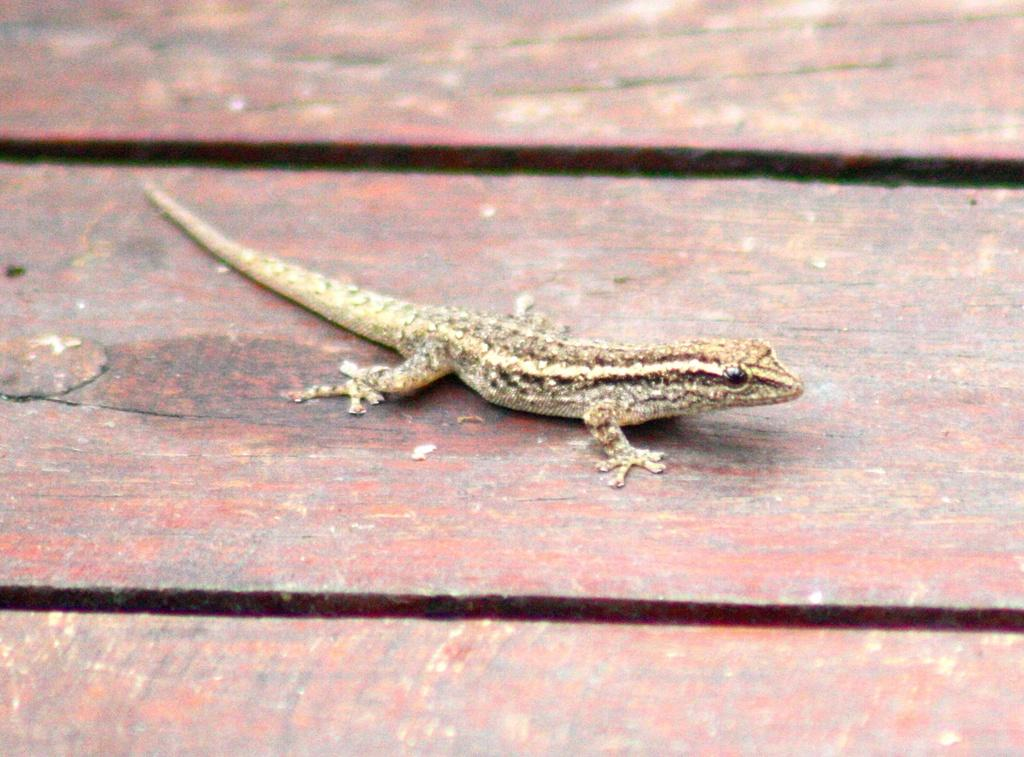What type of animal is in the image? There is a lizard in the image. Where is the lizard located? The lizard is on a wooden table. What type of fruit is the lizard holding in the image? There is no fruit present in the image, and the lizard is not holding anything. 